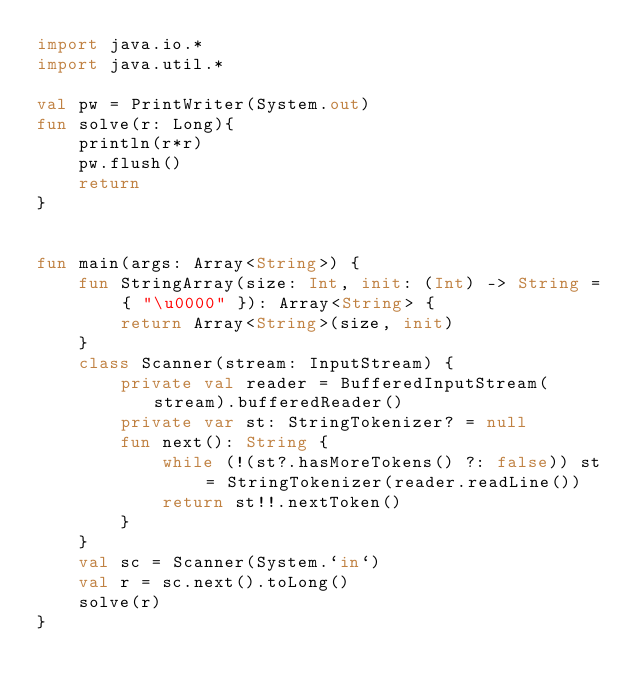Convert code to text. <code><loc_0><loc_0><loc_500><loc_500><_Kotlin_>import java.io.*
import java.util.*

val pw = PrintWriter(System.out)
fun solve(r: Long){
    println(r*r)
    pw.flush()
    return
}


fun main(args: Array<String>) {
    fun StringArray(size: Int, init: (Int) -> String = { "\u0000" }): Array<String> {
        return Array<String>(size, init)
    }
    class Scanner(stream: InputStream) {
        private val reader = BufferedInputStream(stream).bufferedReader()
        private var st: StringTokenizer? = null
        fun next(): String {
            while (!(st?.hasMoreTokens() ?: false)) st = StringTokenizer(reader.readLine())
            return st!!.nextToken()
        }
    }
    val sc = Scanner(System.`in`)
    val r = sc.next().toLong()
    solve(r)
}

</code> 